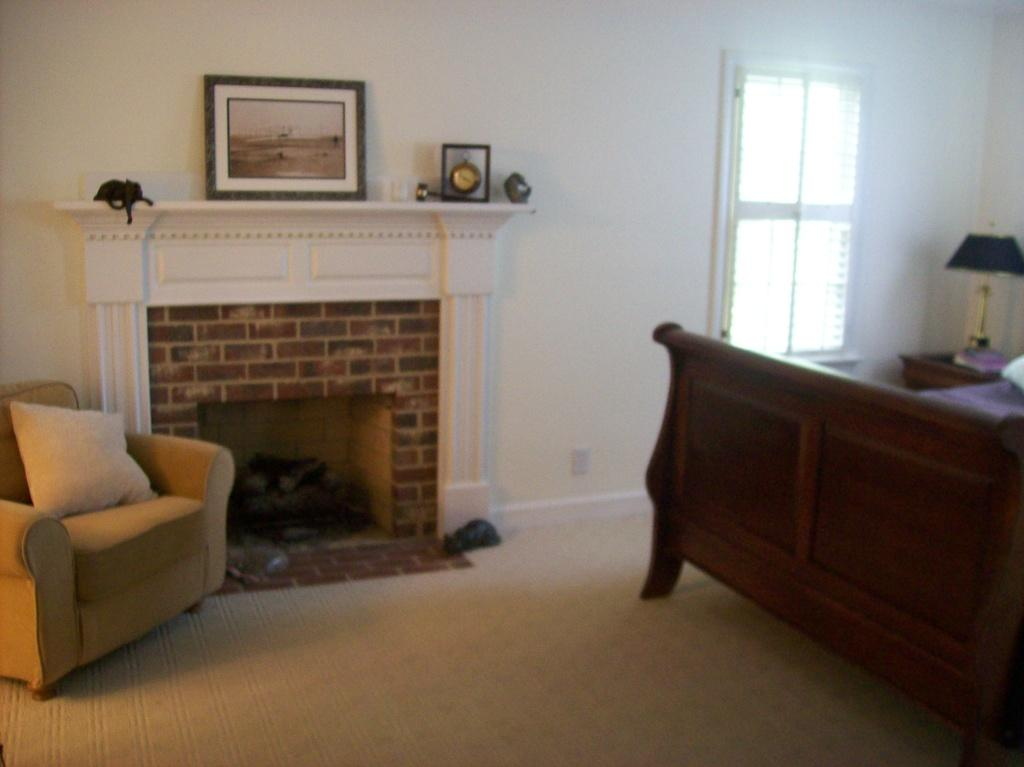What type of furniture is in the image? There is a couch with a pillow in the image. What is located beside the couch? There is a fireplace beside the couch. What is placed on top of the fireplace? There is a photo frame on top of the fireplace. What other piece of furniture can be seen on the right side of the image? There is a bed on the right side of the image. What objects are also on the right side of the image? There is a lamp and a window on the right side of the image. What is the income of the person who owns the couch in the image? There is no information about the income of the person who owns the couch in the image. What time of day is depicted in the image? The time of day is not specified in the image. 